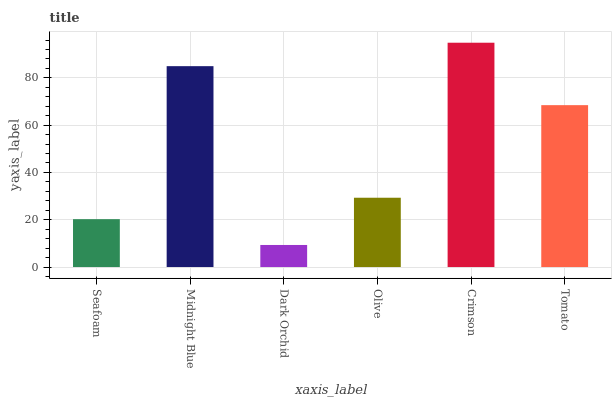Is Dark Orchid the minimum?
Answer yes or no. Yes. Is Crimson the maximum?
Answer yes or no. Yes. Is Midnight Blue the minimum?
Answer yes or no. No. Is Midnight Blue the maximum?
Answer yes or no. No. Is Midnight Blue greater than Seafoam?
Answer yes or no. Yes. Is Seafoam less than Midnight Blue?
Answer yes or no. Yes. Is Seafoam greater than Midnight Blue?
Answer yes or no. No. Is Midnight Blue less than Seafoam?
Answer yes or no. No. Is Tomato the high median?
Answer yes or no. Yes. Is Olive the low median?
Answer yes or no. Yes. Is Olive the high median?
Answer yes or no. No. Is Seafoam the low median?
Answer yes or no. No. 